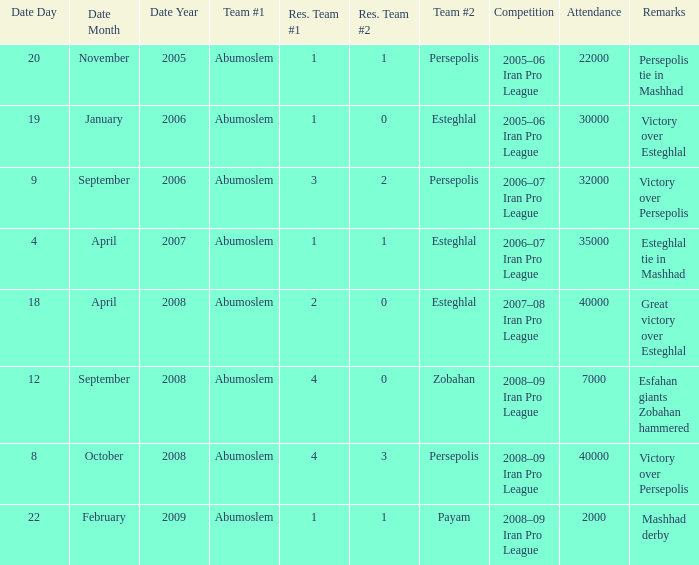What was the res for the game against Payam? 1–1. 